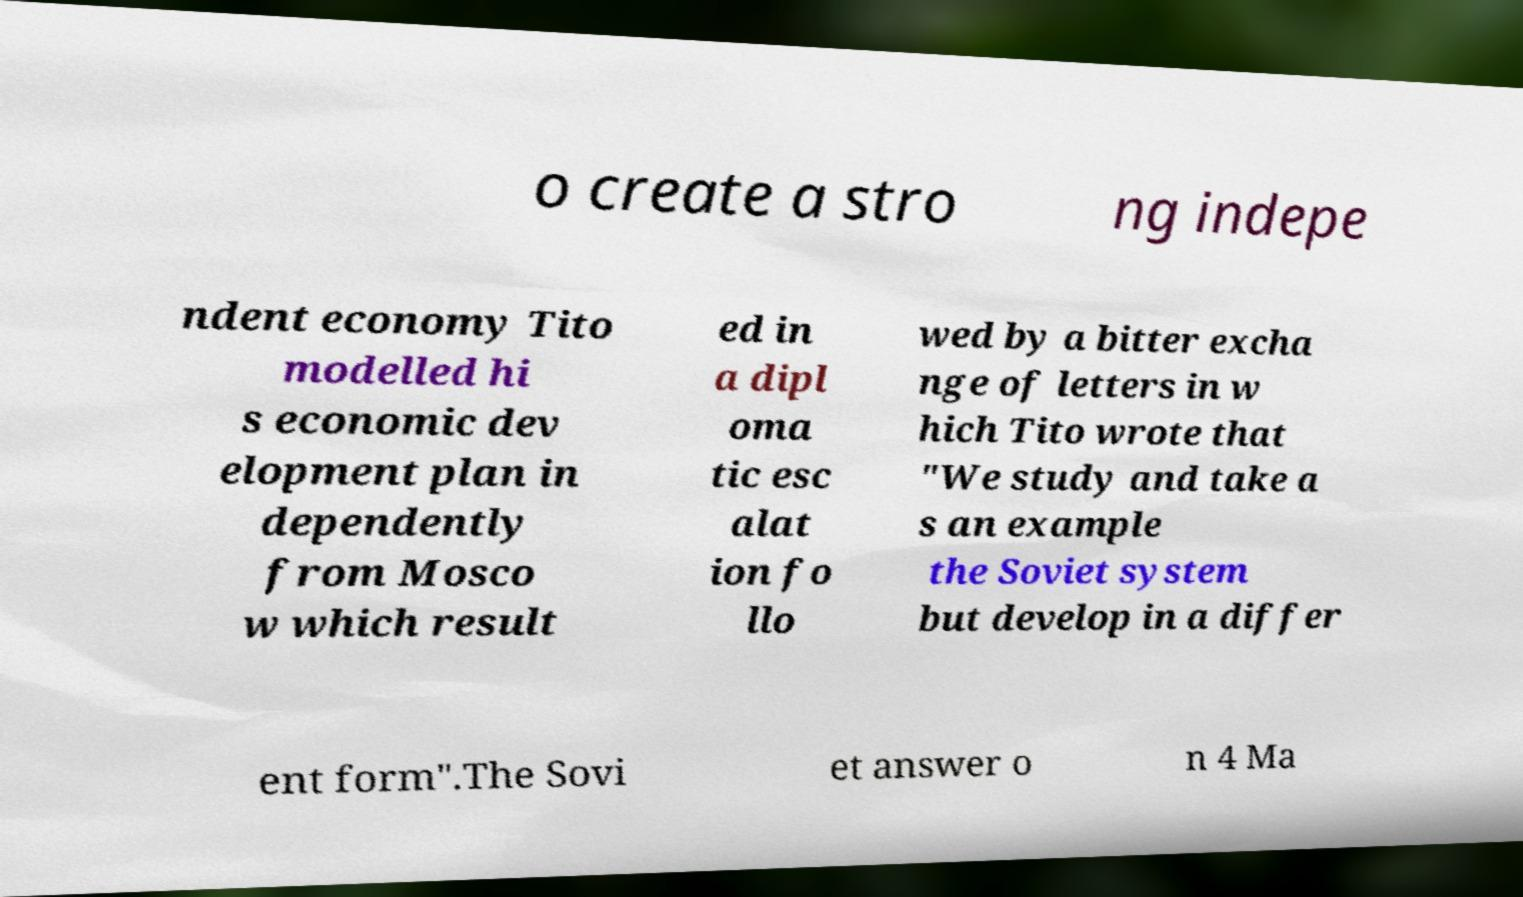Can you accurately transcribe the text from the provided image for me? o create a stro ng indepe ndent economy Tito modelled hi s economic dev elopment plan in dependently from Mosco w which result ed in a dipl oma tic esc alat ion fo llo wed by a bitter excha nge of letters in w hich Tito wrote that "We study and take a s an example the Soviet system but develop in a differ ent form".The Sovi et answer o n 4 Ma 